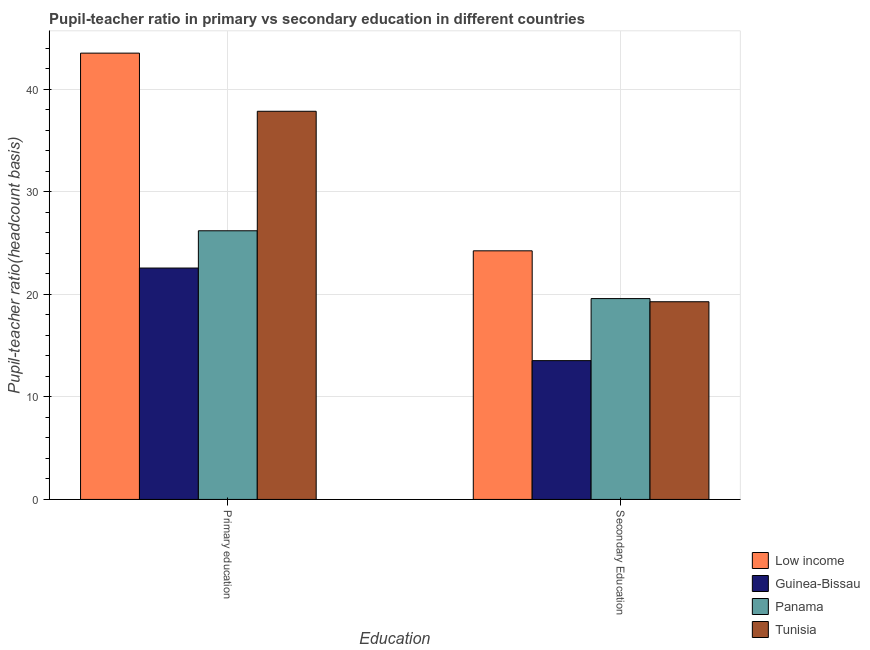How many different coloured bars are there?
Your answer should be very brief. 4. How many groups of bars are there?
Make the answer very short. 2. How many bars are there on the 2nd tick from the right?
Ensure brevity in your answer.  4. What is the label of the 2nd group of bars from the left?
Offer a very short reply. Secondary Education. What is the pupil teacher ratio on secondary education in Tunisia?
Keep it short and to the point. 19.28. Across all countries, what is the maximum pupil-teacher ratio in primary education?
Provide a short and direct response. 43.52. Across all countries, what is the minimum pupil teacher ratio on secondary education?
Provide a succinct answer. 13.54. In which country was the pupil teacher ratio on secondary education maximum?
Your response must be concise. Low income. In which country was the pupil-teacher ratio in primary education minimum?
Your answer should be very brief. Guinea-Bissau. What is the total pupil-teacher ratio in primary education in the graph?
Your answer should be very brief. 130.14. What is the difference between the pupil teacher ratio on secondary education in Tunisia and that in Panama?
Provide a succinct answer. -0.31. What is the difference between the pupil teacher ratio on secondary education in Tunisia and the pupil-teacher ratio in primary education in Panama?
Keep it short and to the point. -6.92. What is the average pupil-teacher ratio in primary education per country?
Keep it short and to the point. 32.54. What is the difference between the pupil teacher ratio on secondary education and pupil-teacher ratio in primary education in Tunisia?
Your answer should be compact. -18.58. What is the ratio of the pupil teacher ratio on secondary education in Tunisia to that in Guinea-Bissau?
Your answer should be very brief. 1.42. In how many countries, is the pupil teacher ratio on secondary education greater than the average pupil teacher ratio on secondary education taken over all countries?
Give a very brief answer. 3. What does the 4th bar from the left in Primary education represents?
Offer a terse response. Tunisia. Are all the bars in the graph horizontal?
Offer a very short reply. No. How many countries are there in the graph?
Make the answer very short. 4. What is the difference between two consecutive major ticks on the Y-axis?
Ensure brevity in your answer.  10. Does the graph contain grids?
Ensure brevity in your answer.  Yes. Where does the legend appear in the graph?
Ensure brevity in your answer.  Bottom right. How are the legend labels stacked?
Keep it short and to the point. Vertical. What is the title of the graph?
Provide a succinct answer. Pupil-teacher ratio in primary vs secondary education in different countries. What is the label or title of the X-axis?
Your response must be concise. Education. What is the label or title of the Y-axis?
Your answer should be compact. Pupil-teacher ratio(headcount basis). What is the Pupil-teacher ratio(headcount basis) in Low income in Primary education?
Offer a terse response. 43.52. What is the Pupil-teacher ratio(headcount basis) in Guinea-Bissau in Primary education?
Your response must be concise. 22.57. What is the Pupil-teacher ratio(headcount basis) of Panama in Primary education?
Make the answer very short. 26.2. What is the Pupil-teacher ratio(headcount basis) of Tunisia in Primary education?
Your response must be concise. 37.85. What is the Pupil-teacher ratio(headcount basis) in Low income in Secondary Education?
Provide a short and direct response. 24.25. What is the Pupil-teacher ratio(headcount basis) in Guinea-Bissau in Secondary Education?
Your response must be concise. 13.54. What is the Pupil-teacher ratio(headcount basis) of Panama in Secondary Education?
Provide a short and direct response. 19.59. What is the Pupil-teacher ratio(headcount basis) of Tunisia in Secondary Education?
Provide a succinct answer. 19.28. Across all Education, what is the maximum Pupil-teacher ratio(headcount basis) in Low income?
Ensure brevity in your answer.  43.52. Across all Education, what is the maximum Pupil-teacher ratio(headcount basis) in Guinea-Bissau?
Your answer should be compact. 22.57. Across all Education, what is the maximum Pupil-teacher ratio(headcount basis) of Panama?
Offer a terse response. 26.2. Across all Education, what is the maximum Pupil-teacher ratio(headcount basis) in Tunisia?
Offer a very short reply. 37.85. Across all Education, what is the minimum Pupil-teacher ratio(headcount basis) of Low income?
Offer a terse response. 24.25. Across all Education, what is the minimum Pupil-teacher ratio(headcount basis) of Guinea-Bissau?
Keep it short and to the point. 13.54. Across all Education, what is the minimum Pupil-teacher ratio(headcount basis) in Panama?
Ensure brevity in your answer.  19.59. Across all Education, what is the minimum Pupil-teacher ratio(headcount basis) of Tunisia?
Provide a succinct answer. 19.28. What is the total Pupil-teacher ratio(headcount basis) in Low income in the graph?
Make the answer very short. 67.77. What is the total Pupil-teacher ratio(headcount basis) in Guinea-Bissau in the graph?
Make the answer very short. 36.1. What is the total Pupil-teacher ratio(headcount basis) in Panama in the graph?
Your answer should be compact. 45.79. What is the total Pupil-teacher ratio(headcount basis) of Tunisia in the graph?
Offer a terse response. 57.13. What is the difference between the Pupil-teacher ratio(headcount basis) of Low income in Primary education and that in Secondary Education?
Offer a terse response. 19.28. What is the difference between the Pupil-teacher ratio(headcount basis) in Guinea-Bissau in Primary education and that in Secondary Education?
Your answer should be compact. 9.03. What is the difference between the Pupil-teacher ratio(headcount basis) of Panama in Primary education and that in Secondary Education?
Keep it short and to the point. 6.61. What is the difference between the Pupil-teacher ratio(headcount basis) of Tunisia in Primary education and that in Secondary Education?
Keep it short and to the point. 18.58. What is the difference between the Pupil-teacher ratio(headcount basis) of Low income in Primary education and the Pupil-teacher ratio(headcount basis) of Guinea-Bissau in Secondary Education?
Ensure brevity in your answer.  29.99. What is the difference between the Pupil-teacher ratio(headcount basis) of Low income in Primary education and the Pupil-teacher ratio(headcount basis) of Panama in Secondary Education?
Ensure brevity in your answer.  23.94. What is the difference between the Pupil-teacher ratio(headcount basis) of Low income in Primary education and the Pupil-teacher ratio(headcount basis) of Tunisia in Secondary Education?
Provide a short and direct response. 24.25. What is the difference between the Pupil-teacher ratio(headcount basis) of Guinea-Bissau in Primary education and the Pupil-teacher ratio(headcount basis) of Panama in Secondary Education?
Provide a succinct answer. 2.98. What is the difference between the Pupil-teacher ratio(headcount basis) of Guinea-Bissau in Primary education and the Pupil-teacher ratio(headcount basis) of Tunisia in Secondary Education?
Offer a terse response. 3.29. What is the difference between the Pupil-teacher ratio(headcount basis) of Panama in Primary education and the Pupil-teacher ratio(headcount basis) of Tunisia in Secondary Education?
Give a very brief answer. 6.92. What is the average Pupil-teacher ratio(headcount basis) of Low income per Education?
Your answer should be compact. 33.88. What is the average Pupil-teacher ratio(headcount basis) of Guinea-Bissau per Education?
Provide a short and direct response. 18.05. What is the average Pupil-teacher ratio(headcount basis) in Panama per Education?
Your answer should be compact. 22.89. What is the average Pupil-teacher ratio(headcount basis) in Tunisia per Education?
Ensure brevity in your answer.  28.57. What is the difference between the Pupil-teacher ratio(headcount basis) of Low income and Pupil-teacher ratio(headcount basis) of Guinea-Bissau in Primary education?
Provide a succinct answer. 20.96. What is the difference between the Pupil-teacher ratio(headcount basis) of Low income and Pupil-teacher ratio(headcount basis) of Panama in Primary education?
Make the answer very short. 17.32. What is the difference between the Pupil-teacher ratio(headcount basis) of Low income and Pupil-teacher ratio(headcount basis) of Tunisia in Primary education?
Provide a succinct answer. 5.67. What is the difference between the Pupil-teacher ratio(headcount basis) of Guinea-Bissau and Pupil-teacher ratio(headcount basis) of Panama in Primary education?
Give a very brief answer. -3.63. What is the difference between the Pupil-teacher ratio(headcount basis) of Guinea-Bissau and Pupil-teacher ratio(headcount basis) of Tunisia in Primary education?
Offer a terse response. -15.29. What is the difference between the Pupil-teacher ratio(headcount basis) in Panama and Pupil-teacher ratio(headcount basis) in Tunisia in Primary education?
Your response must be concise. -11.65. What is the difference between the Pupil-teacher ratio(headcount basis) in Low income and Pupil-teacher ratio(headcount basis) in Guinea-Bissau in Secondary Education?
Your response must be concise. 10.71. What is the difference between the Pupil-teacher ratio(headcount basis) of Low income and Pupil-teacher ratio(headcount basis) of Panama in Secondary Education?
Offer a very short reply. 4.66. What is the difference between the Pupil-teacher ratio(headcount basis) of Low income and Pupil-teacher ratio(headcount basis) of Tunisia in Secondary Education?
Your response must be concise. 4.97. What is the difference between the Pupil-teacher ratio(headcount basis) in Guinea-Bissau and Pupil-teacher ratio(headcount basis) in Panama in Secondary Education?
Give a very brief answer. -6.05. What is the difference between the Pupil-teacher ratio(headcount basis) in Guinea-Bissau and Pupil-teacher ratio(headcount basis) in Tunisia in Secondary Education?
Ensure brevity in your answer.  -5.74. What is the difference between the Pupil-teacher ratio(headcount basis) of Panama and Pupil-teacher ratio(headcount basis) of Tunisia in Secondary Education?
Ensure brevity in your answer.  0.31. What is the ratio of the Pupil-teacher ratio(headcount basis) of Low income in Primary education to that in Secondary Education?
Your response must be concise. 1.8. What is the ratio of the Pupil-teacher ratio(headcount basis) in Guinea-Bissau in Primary education to that in Secondary Education?
Provide a short and direct response. 1.67. What is the ratio of the Pupil-teacher ratio(headcount basis) of Panama in Primary education to that in Secondary Education?
Give a very brief answer. 1.34. What is the ratio of the Pupil-teacher ratio(headcount basis) of Tunisia in Primary education to that in Secondary Education?
Your answer should be compact. 1.96. What is the difference between the highest and the second highest Pupil-teacher ratio(headcount basis) in Low income?
Give a very brief answer. 19.28. What is the difference between the highest and the second highest Pupil-teacher ratio(headcount basis) in Guinea-Bissau?
Offer a terse response. 9.03. What is the difference between the highest and the second highest Pupil-teacher ratio(headcount basis) in Panama?
Provide a succinct answer. 6.61. What is the difference between the highest and the second highest Pupil-teacher ratio(headcount basis) of Tunisia?
Give a very brief answer. 18.58. What is the difference between the highest and the lowest Pupil-teacher ratio(headcount basis) in Low income?
Your response must be concise. 19.28. What is the difference between the highest and the lowest Pupil-teacher ratio(headcount basis) in Guinea-Bissau?
Offer a very short reply. 9.03. What is the difference between the highest and the lowest Pupil-teacher ratio(headcount basis) of Panama?
Offer a very short reply. 6.61. What is the difference between the highest and the lowest Pupil-teacher ratio(headcount basis) in Tunisia?
Ensure brevity in your answer.  18.58. 